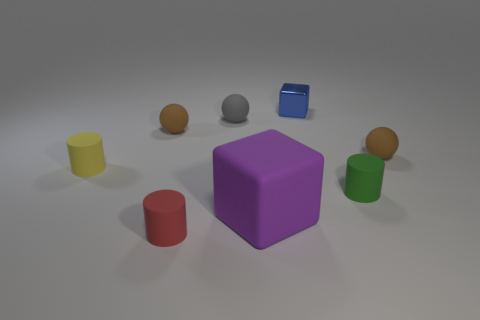Add 1 green spheres. How many objects exist? 9 Subtract all cylinders. How many objects are left? 5 Add 4 small green matte cylinders. How many small green matte cylinders exist? 5 Subtract 0 cyan balls. How many objects are left? 8 Subtract all small blue spheres. Subtract all gray matte things. How many objects are left? 7 Add 6 rubber cubes. How many rubber cubes are left? 7 